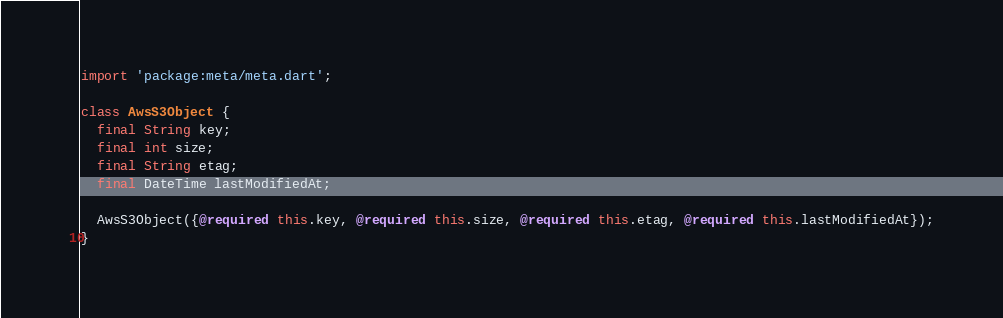Convert code to text. <code><loc_0><loc_0><loc_500><loc_500><_Dart_>import 'package:meta/meta.dart';

class AwsS3Object {
  final String key;
  final int size;
  final String etag;
  final DateTime lastModifiedAt;

  AwsS3Object({@required this.key, @required this.size, @required this.etag, @required this.lastModifiedAt});
}
</code> 